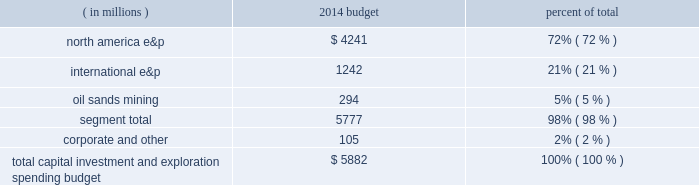Outlook budget our board of directors approved a capital , investment and exploration spending budget of $ 5882 million for 2014 , including budgeted capital expenditures of $ 5777 million .
Our capital , investment and exploration spending budget is broken down by reportable segment in the table below .
( in millions ) 2014 budget percent of .
We continue to focus on growing profitable reserves and production worldwide .
In 2014 , we are accelerating drilling activity in our three key u.s .
Unconventional resource plays : the eagle ford , bakken and oklahoma resource basins , which account for approximately 60 percent of our budget .
The majority of spending in our unconventional resource plays is intended for drilling .
With an increased number of rigs in each of these areas , we plan to drill more net wells in these areas than in any previous year .
We also have dedicated a portion of our capital budget in these areas to facility construction and recompletions .
In our conventional assets , we will follow a disciplined spending plan that is intended to provide stable productionwith approximately 23 percent of our budget allocated to the development of these assets worldwide .
We also plan to either drill or participate in 8 to 10 exploration wells throughout our portfolio , with 10 percent of our budget allocated to exploration projects .
For additional information about expected exploration and development activities see item 1 .
Business .
The above discussion includes forward-looking statements with respect to projected spending and investment in exploration and development activities under the 2014 capital , investment and exploration spending budget , accelerated rig and drilling activity in the eagle ford , bakken , and oklahoma resource basins , and future exploratory and development drilling activity .
Some factors which could potentially affect these forward-looking statements include pricing , supply and demand for liquid hydrocarbons and natural gas , the amount of capital available for exploration and development , regulatory constraints , timing of commencing production from new wells , drilling rig availability , availability of materials and labor , other risks associated with construction projects , unforeseen hazards such as weather conditions , acts of war or terrorist acts and the governmental or military response , and other geological , operating and economic considerations .
These forward-looking statements may be further affected by the inability to obtain or delay in obtaining necessary government and third-party approvals or permits .
The development projects could further be affected by presently known data concerning size and character of reservoirs , economic recoverability , future drilling success and production experience .
The foregoing factors ( among others ) could cause actual results to differ materially from those set forth in the forward-looking statements .
Sales volumes we expect to increase our u.s .
Resource plays' net sales volumes by more than 30 percent in 2014 compared to 2013 , excluding dispositions .
In addition , we expect total production growth to be approximately 4 percent in 2014 versus 2013 , excluding dispositions and libya .
Acquisitions and dispositions excluded from our budget are the impacts of acquisitions and dispositions not previously announced .
We continually evaluate ways to optimize our portfolio through acquisitions and divestitures and exceeded our previously stated goal of divesting between $ 1.5 billion and $ 3.0 billion of assets over the period of 2011 through 2013 .
For the three-year period ended december 31 , 2013 , we closed or entered agreements for approximately $ 3.5 billion in divestitures , of which $ 2.1 billion is from the sales of our angola assets .
The sale of our interest in angola block 31 closed in february 2014 and the sale of our interest in angola block 32 is expected to close in the first quarter of 2014 .
In december 2013 , we announced the commencement of efforts to market our assets in the north sea , both in the u.k .
And norway , which would simplify and concentrate our portfolio to higher margin growth opportunities and increase our production growth rate .
The above discussion includes forward-looking statements with respect to our percentage growth rate of production , production available for sale , the sale of our interest in angola block 32 and the possible sale of our u.k .
And norway assets .
Some factors .
Capital expenses were what percent of total capital , investment and exploration spending budget for 2014? 
Computations: (5777 / 5882)
Answer: 0.98215. 